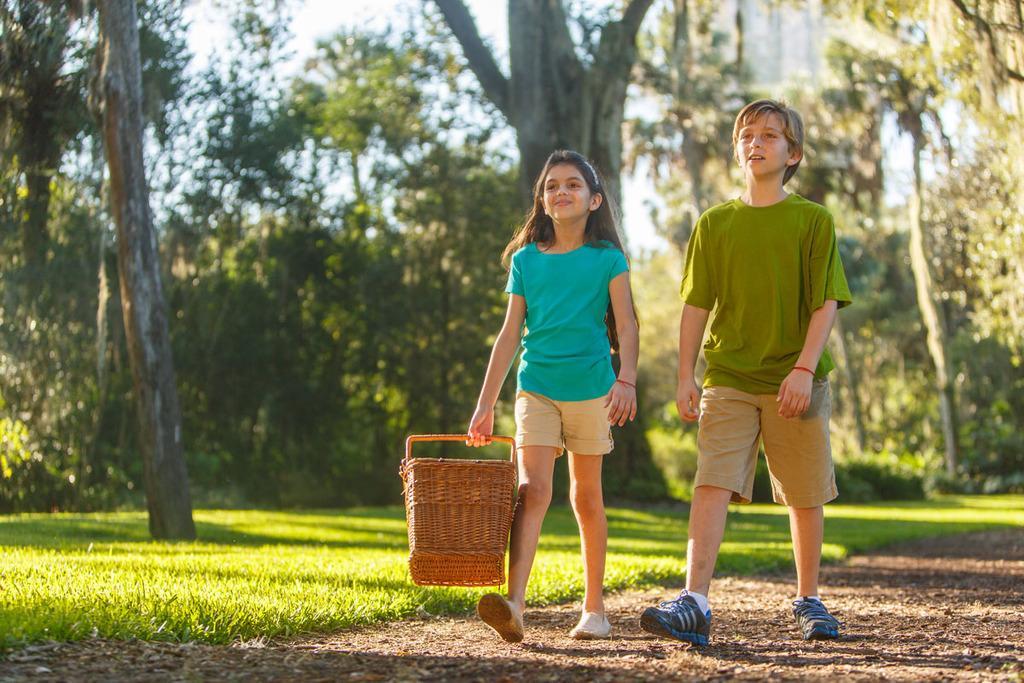Please provide a concise description of this image. In this image we can see a boy and a girl with a basket are walking on the ground. In the background we can see many trees. We can also see the grass. 